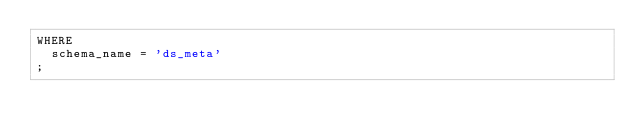<code> <loc_0><loc_0><loc_500><loc_500><_SQL_>WHERE
  schema_name = 'ds_meta'
;
</code> 